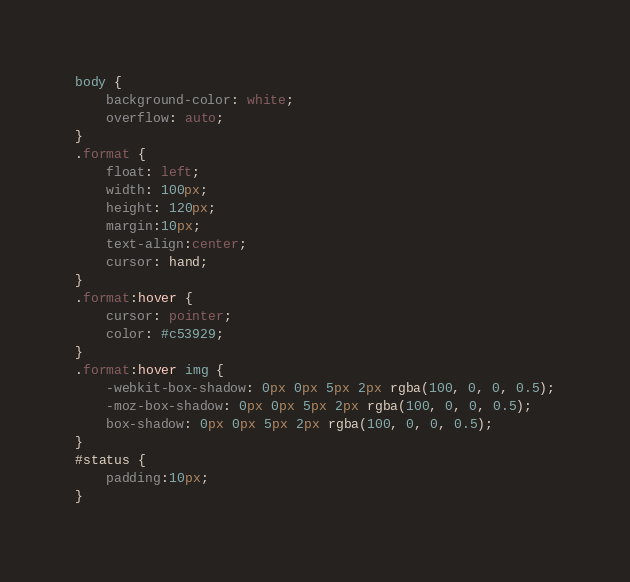<code> <loc_0><loc_0><loc_500><loc_500><_CSS_>body {
    background-color: white;
    overflow: auto;
}
.format {
    float: left;
    width: 100px;
    height: 120px;
    margin:10px;
    text-align:center;
    cursor: hand;
}
.format:hover {
    cursor: pointer;
    color: #c53929;
}
.format:hover img {
    -webkit-box-shadow: 0px 0px 5px 2px rgba(100, 0, 0, 0.5);
    -moz-box-shadow: 0px 0px 5px 2px rgba(100, 0, 0, 0.5);
    box-shadow: 0px 0px 5px 2px rgba(100, 0, 0, 0.5);
}
#status {
    padding:10px;
}</code> 